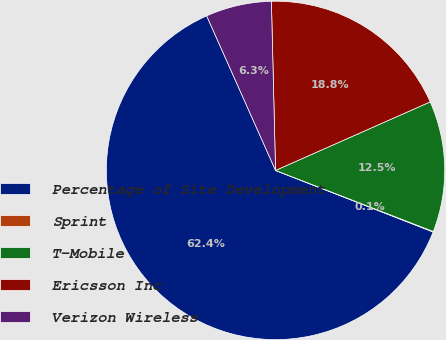Convert chart to OTSL. <chart><loc_0><loc_0><loc_500><loc_500><pie_chart><fcel>Percentage of Site Development<fcel>Sprint<fcel>T-Mobile<fcel>Ericsson Inc<fcel>Verizon Wireless<nl><fcel>62.4%<fcel>0.05%<fcel>12.52%<fcel>18.75%<fcel>6.28%<nl></chart> 